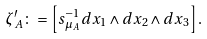<formula> <loc_0><loc_0><loc_500><loc_500>\zeta _ { A } ^ { \prime } \colon = \left [ s _ { \mu _ { A } } ^ { - 1 } d x _ { 1 } \wedge d x _ { 2 } \wedge d x _ { 3 } \right ] .</formula> 